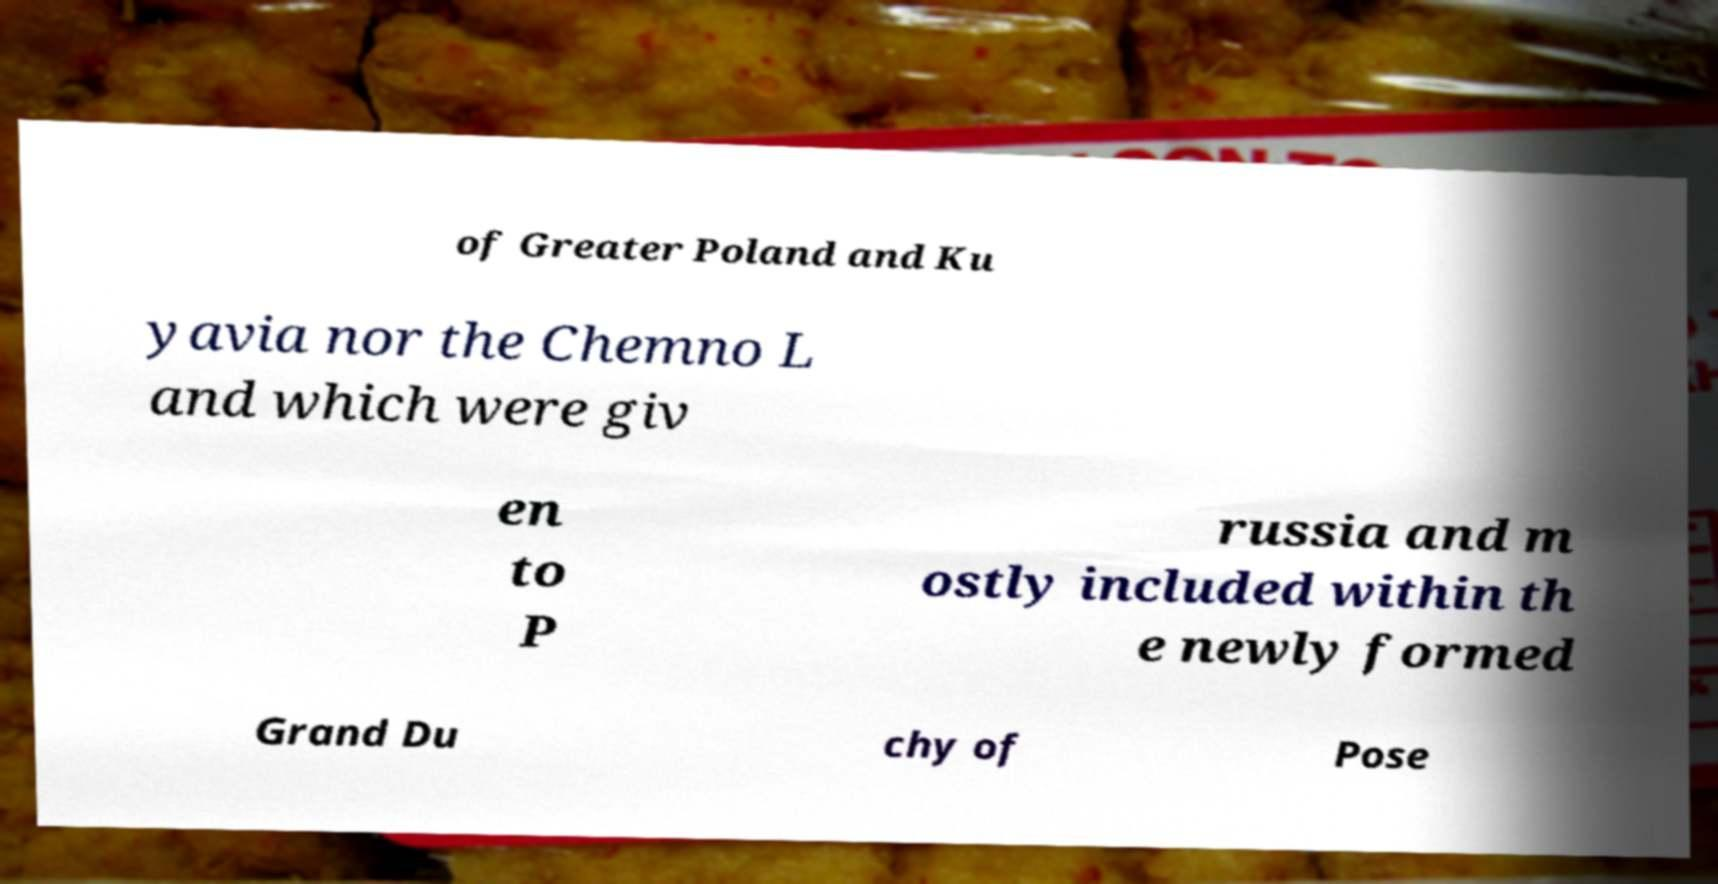What messages or text are displayed in this image? I need them in a readable, typed format. of Greater Poland and Ku yavia nor the Chemno L and which were giv en to P russia and m ostly included within th e newly formed Grand Du chy of Pose 